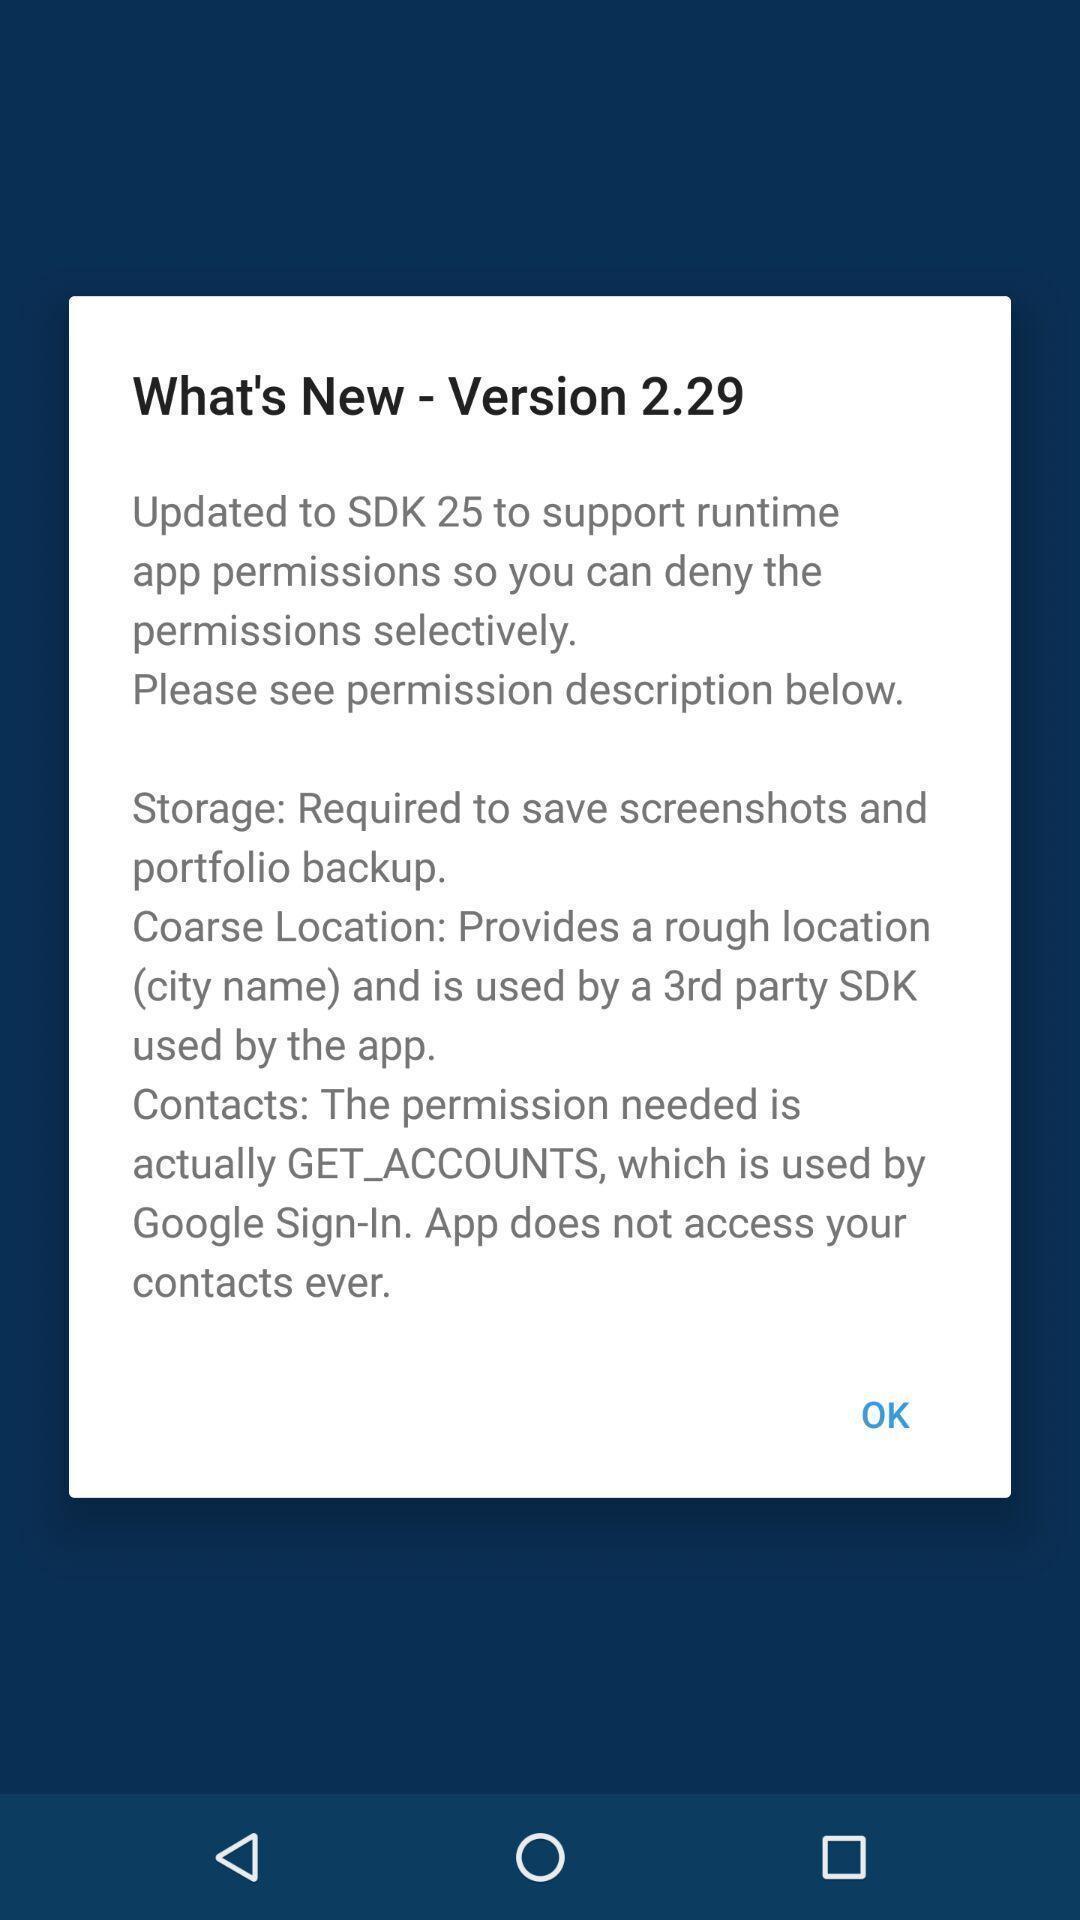Provide a description of this screenshot. Screen displaying new version notification. 